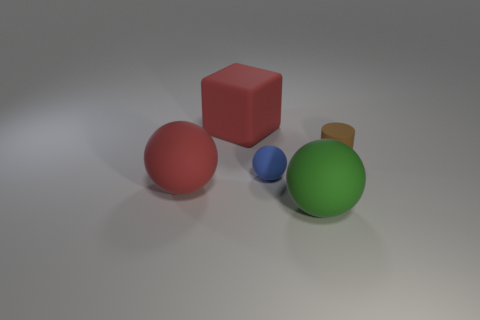What is the color of the big matte sphere that is behind the large green thing that is to the right of the blue sphere?
Your answer should be compact. Red. Do the red sphere and the red block have the same size?
Provide a short and direct response. Yes. The matte object that is behind the blue rubber object and in front of the big red rubber block is what color?
Provide a short and direct response. Brown. What is the size of the red rubber ball?
Your answer should be compact. Large. There is a matte thing right of the green matte sphere; is its color the same as the tiny ball?
Give a very brief answer. No. Is the number of large red matte things in front of the red rubber sphere greater than the number of tiny balls that are behind the red cube?
Your response must be concise. No. Is the number of purple cylinders greater than the number of big green objects?
Provide a short and direct response. No. What is the size of the matte thing that is behind the tiny blue object and to the right of the rubber cube?
Your response must be concise. Small. What is the shape of the tiny blue thing?
Your answer should be compact. Sphere. Are there any other things that have the same size as the brown matte thing?
Provide a succinct answer. Yes. 